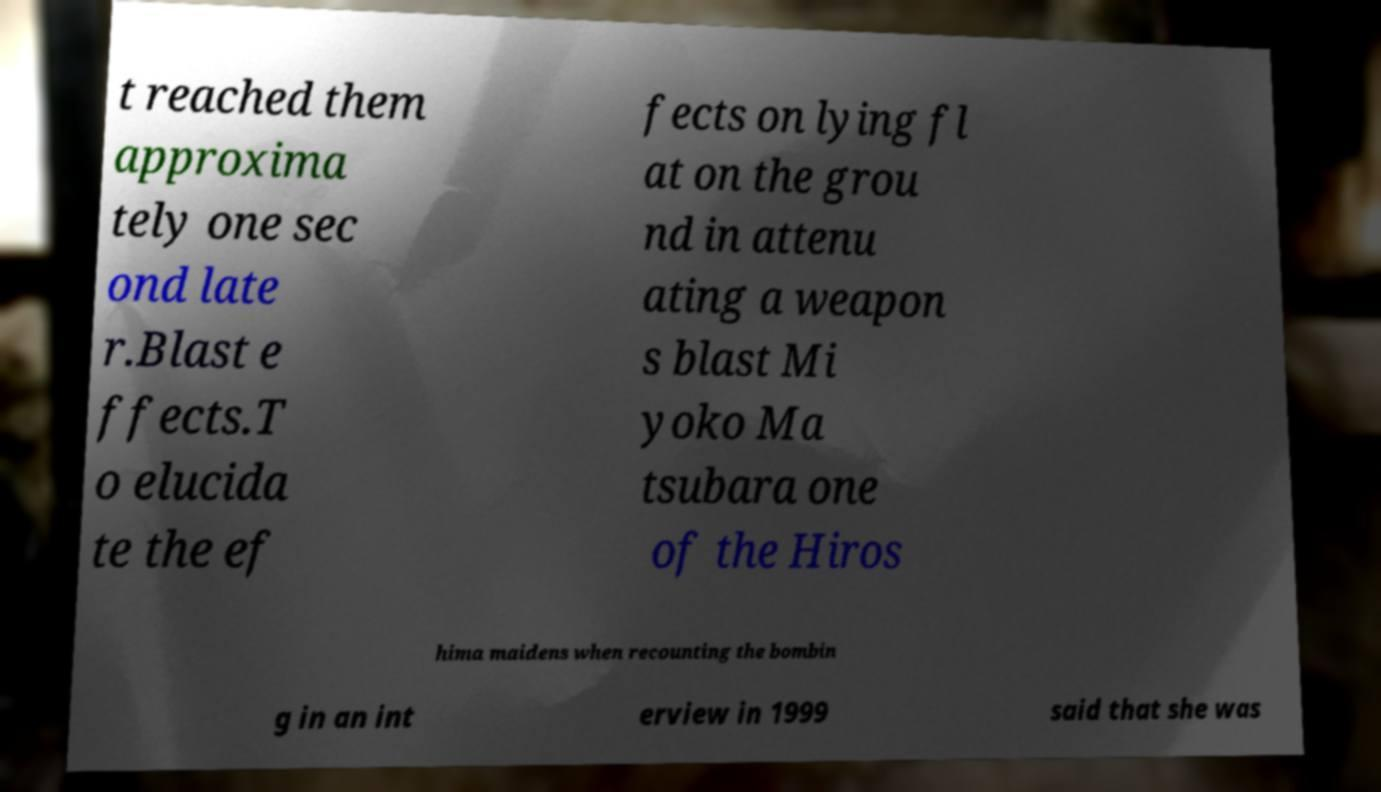There's text embedded in this image that I need extracted. Can you transcribe it verbatim? t reached them approxima tely one sec ond late r.Blast e ffects.T o elucida te the ef fects on lying fl at on the grou nd in attenu ating a weapon s blast Mi yoko Ma tsubara one of the Hiros hima maidens when recounting the bombin g in an int erview in 1999 said that she was 